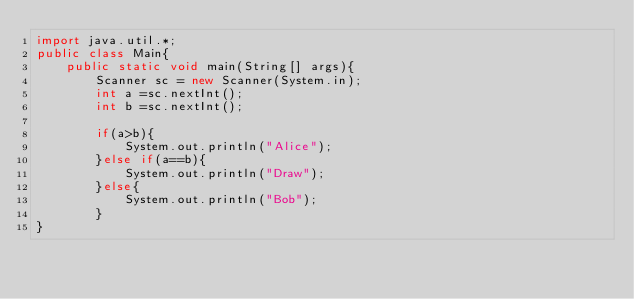<code> <loc_0><loc_0><loc_500><loc_500><_Java_>import java.util.*;
public class Main{
    public static void main(String[] args){
        Scanner sc = new Scanner(System.in);
        int a =sc.nextInt();
        int b =sc.nextInt();

        if(a>b){
            System.out.println("Alice");
        }else if(a==b){
            System.out.println("Draw");
        }else{
            System.out.println("Bob");
        }
}
</code> 